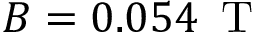<formula> <loc_0><loc_0><loc_500><loc_500>B = 0 . 0 5 4 \, T</formula> 